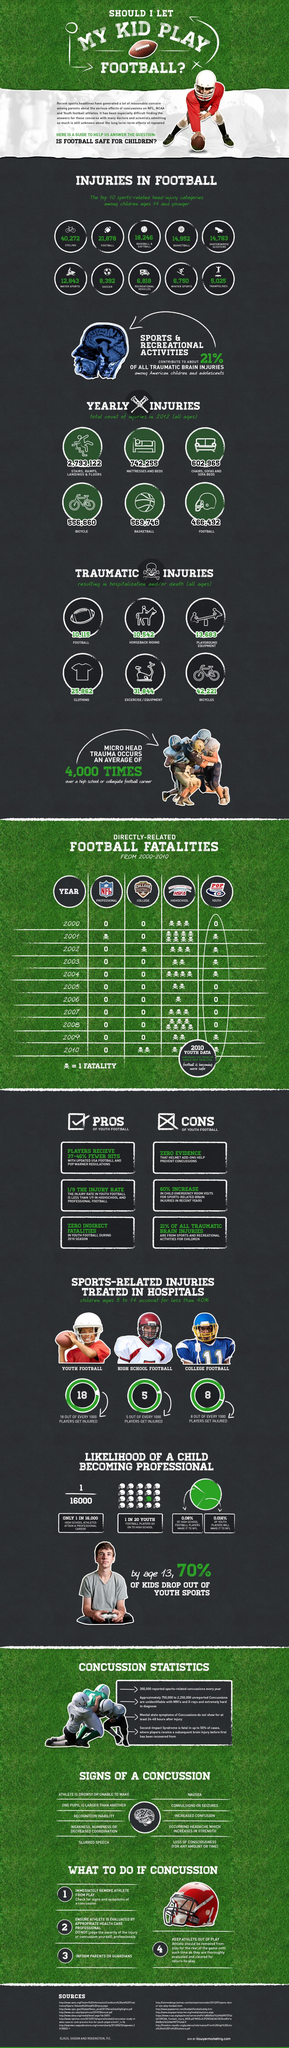How many skulls are shown corresponding to 2000 under HIGHSCHOOL column?
Answer the question with a short phrase. 3 How many head injuries are caused due to winter sports and water sports? 19,593 What does the skull symbol represent? 1 FATALITY How many sources are listed at the bottom? 11 What percent of players get injured during high school football? 0.5% How many injuries are reported in sports involving balls? 63,468 What percent of high school and youth players make it to NFL? 0.096% 